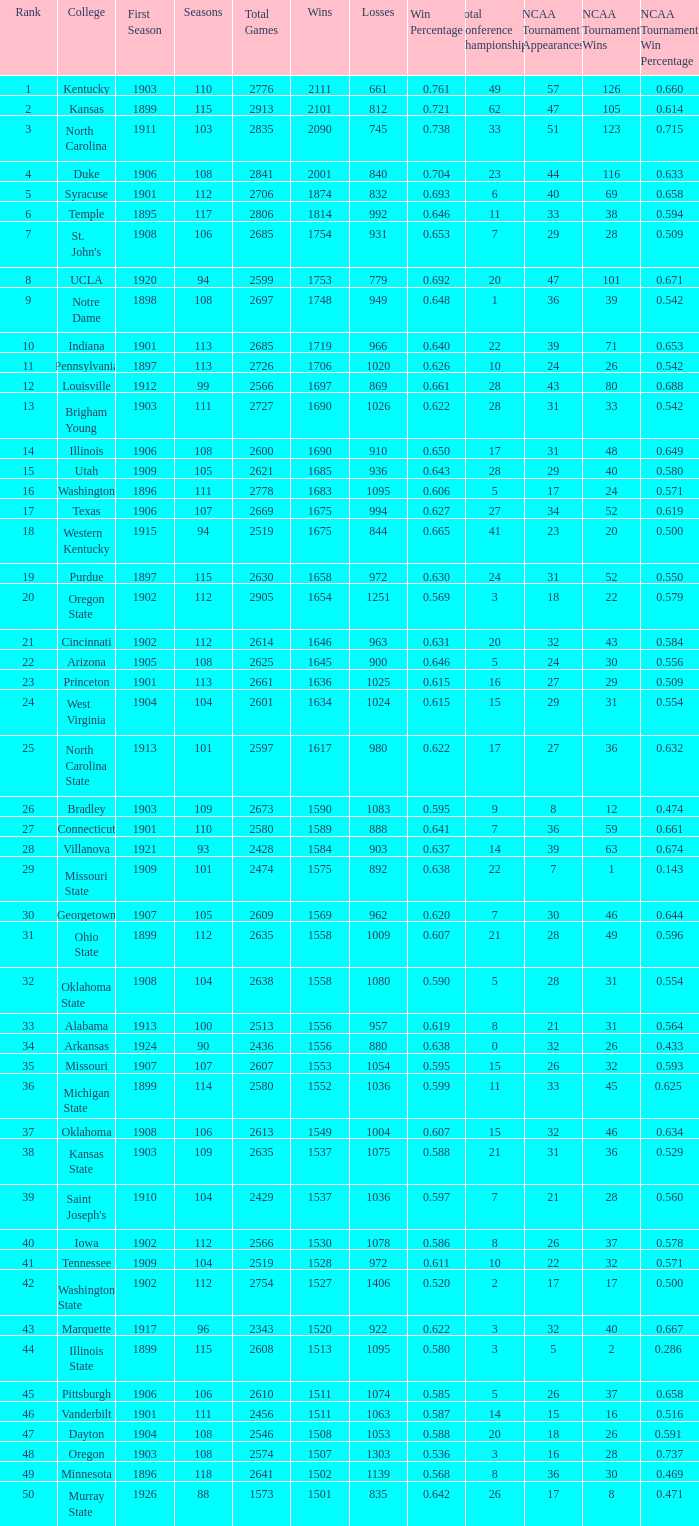Write the full table. {'header': ['Rank', 'College', 'First Season', 'Seasons', 'Total Games', 'Wins', 'Losses', 'Win Percentage', 'Total Conference Championships', 'NCAA Tournament Appearances', 'NCAA Tournament Wins', 'NCAA Tournament Win Percentage '], 'rows': [['1', 'Kentucky', '1903', '110', '2776', '2111', '661', '0.761', '49', '57', '126', '0.660'], ['2', 'Kansas', '1899', '115', '2913', '2101', '812', '0.721', '62', '47', '105', '0.614'], ['3', 'North Carolina', '1911', '103', '2835', '2090', '745', '0.738', '33', '51', '123', '0.715'], ['4', 'Duke', '1906', '108', '2841', '2001', '840', '0.704', '23', '44', '116', '0.633'], ['5', 'Syracuse', '1901', '112', '2706', '1874', '832', '0.693', '6', '40', '69', '0.658'], ['6', 'Temple', '1895', '117', '2806', '1814', '992', '0.646', '11', '33', '38', '0.594'], ['7', "St. John's", '1908', '106', '2685', '1754', '931', '0.653', '7', '29', '28', '0.509'], ['8', 'UCLA', '1920', '94', '2599', '1753', '779', '0.692', '20', '47', '101', '0.671'], ['9', 'Notre Dame', '1898', '108', '2697', '1748', '949', '0.648', '1', '36', '39', '0.542'], ['10', 'Indiana', '1901', '113', '2685', '1719', '966', '0.640', '22', '39', '71', '0.653'], ['11', 'Pennsylvania', '1897', '113', '2726', '1706', '1020', '0.626', '10', '24', '26', '0.542'], ['12', 'Louisville', '1912', '99', '2566', '1697', '869', '0.661', '28', '43', '80', '0.688'], ['13', 'Brigham Young', '1903', '111', '2727', '1690', '1026', '0.622', '28', '31', '33', '0.542'], ['14', 'Illinois', '1906', '108', '2600', '1690', '910', '0.650', '17', '31', '48', '0.649'], ['15', 'Utah', '1909', '105', '2621', '1685', '936', '0.643', '28', '29', '40', '0.580'], ['16', 'Washington', '1896', '111', '2778', '1683', '1095', '0.606', '5', '17', '24', '0.571'], ['17', 'Texas', '1906', '107', '2669', '1675', '994', '0.627', '27', '34', '52', '0.619'], ['18', 'Western Kentucky', '1915', '94', '2519', '1675', '844', '0.665', '41', '23', '20', '0.500'], ['19', 'Purdue', '1897', '115', '2630', '1658', '972', '0.630', '24', '31', '52', '0.550'], ['20', 'Oregon State', '1902', '112', '2905', '1654', '1251', '0.569', '3', '18', '22', '0.579'], ['21', 'Cincinnati', '1902', '112', '2614', '1646', '963', '0.631', '20', '32', '43', '0.584'], ['22', 'Arizona', '1905', '108', '2625', '1645', '900', '0.646', '5', '24', '30', '0.556'], ['23', 'Princeton', '1901', '113', '2661', '1636', '1025', '0.615', '16', '27', '29', '0.509'], ['24', 'West Virginia', '1904', '104', '2601', '1634', '1024', '0.615', '15', '29', '31', '0.554'], ['25', 'North Carolina State', '1913', '101', '2597', '1617', '980', '0.622', '17', '27', '36', '0.632'], ['26', 'Bradley', '1903', '109', '2673', '1590', '1083', '0.595', '9', '8', '12', '0.474'], ['27', 'Connecticut', '1901', '110', '2580', '1589', '888', '0.641', '7', '36', '59', '0.661'], ['28', 'Villanova', '1921', '93', '2428', '1584', '903', '0.637', '14', '39', '63', '0.674'], ['29', 'Missouri State', '1909', '101', '2474', '1575', '892', '0.638', '22', '7', '1', '0.143'], ['30', 'Georgetown', '1907', '105', '2609', '1569', '962', '0.620', '7', '30', '46', '0.644'], ['31', 'Ohio State', '1899', '112', '2635', '1558', '1009', '0.607', '21', '28', '49', '0.596'], ['32', 'Oklahoma State', '1908', '104', '2638', '1558', '1080', '0.590', '5', '28', '31', '0.554'], ['33', 'Alabama', '1913', '100', '2513', '1556', '957', '0.619', '8', '21', '31', '0.564'], ['34', 'Arkansas', '1924', '90', '2436', '1556', '880', '0.638', '0', '32', '26', '0.433'], ['35', 'Missouri', '1907', '107', '2607', '1553', '1054', '0.595', '15', '26', '32', '0.593'], ['36', 'Michigan State', '1899', '114', '2580', '1552', '1036', '0.599', '11', '33', '45', '0.625 '], ['37', 'Oklahoma', '1908', '106', '2613', '1549', '1004', '0.607', '15', '32', '46', '0.634'], ['38', 'Kansas State', '1903', '109', '2635', '1537', '1075', '0.588', '21', '31', '36', '0.529'], ['39', "Saint Joseph's", '1910', '104', '2429', '1537', '1036', '0.597', '7', '21', '28', '0.560'], ['40', 'Iowa', '1902', '112', '2566', '1530', '1078', '0.586', '8', '26', '37', '0.578'], ['41', 'Tennessee', '1909', '104', '2519', '1528', '972', '0.611', '10', '22', '32', '0.571'], ['42', 'Washington State', '1902', '112', '2754', '1527', '1406', '0.520', '2', '17', '17', '0.500'], ['43', 'Marquette', '1917', '96', '2343', '1520', '922', '0.622', '3', '32', '40', '0.667'], ['44', 'Illinois State', '1899', '115', '2608', '1513', '1095', '0.580', '3', '5', '2', '0.286 '], ['45', 'Pittsburgh', '1906', '106', '2610', '1511', '1074', '0.585', '5', '26', '37', '0.658'], ['46', 'Vanderbilt', '1901', '111', '2456', '1511', '1063', '0.587', '14', '15', '16', '0.516'], ['47', 'Dayton', '1904', '108', '2546', '1508', '1053', '0.588', '20', '18', '26', '0.591 '], ['48', 'Oregon', '1903', '108', '2574', '1507', '1303', '0.536', '3', '16', '28', '0.737'], ['49', 'Minnesota', '1896', '118', '2641', '1502', '1139', '0.568', '8', '36', '30', '0.469'], ['50', 'Murray State', '1926', '88', '1573', '1501', '835', '0.642', '26', '17', '8', '0.471']]} How many wins were there for Washington State College with losses greater than 980 and a first season before 1906 and rank greater than 42? 0.0. 